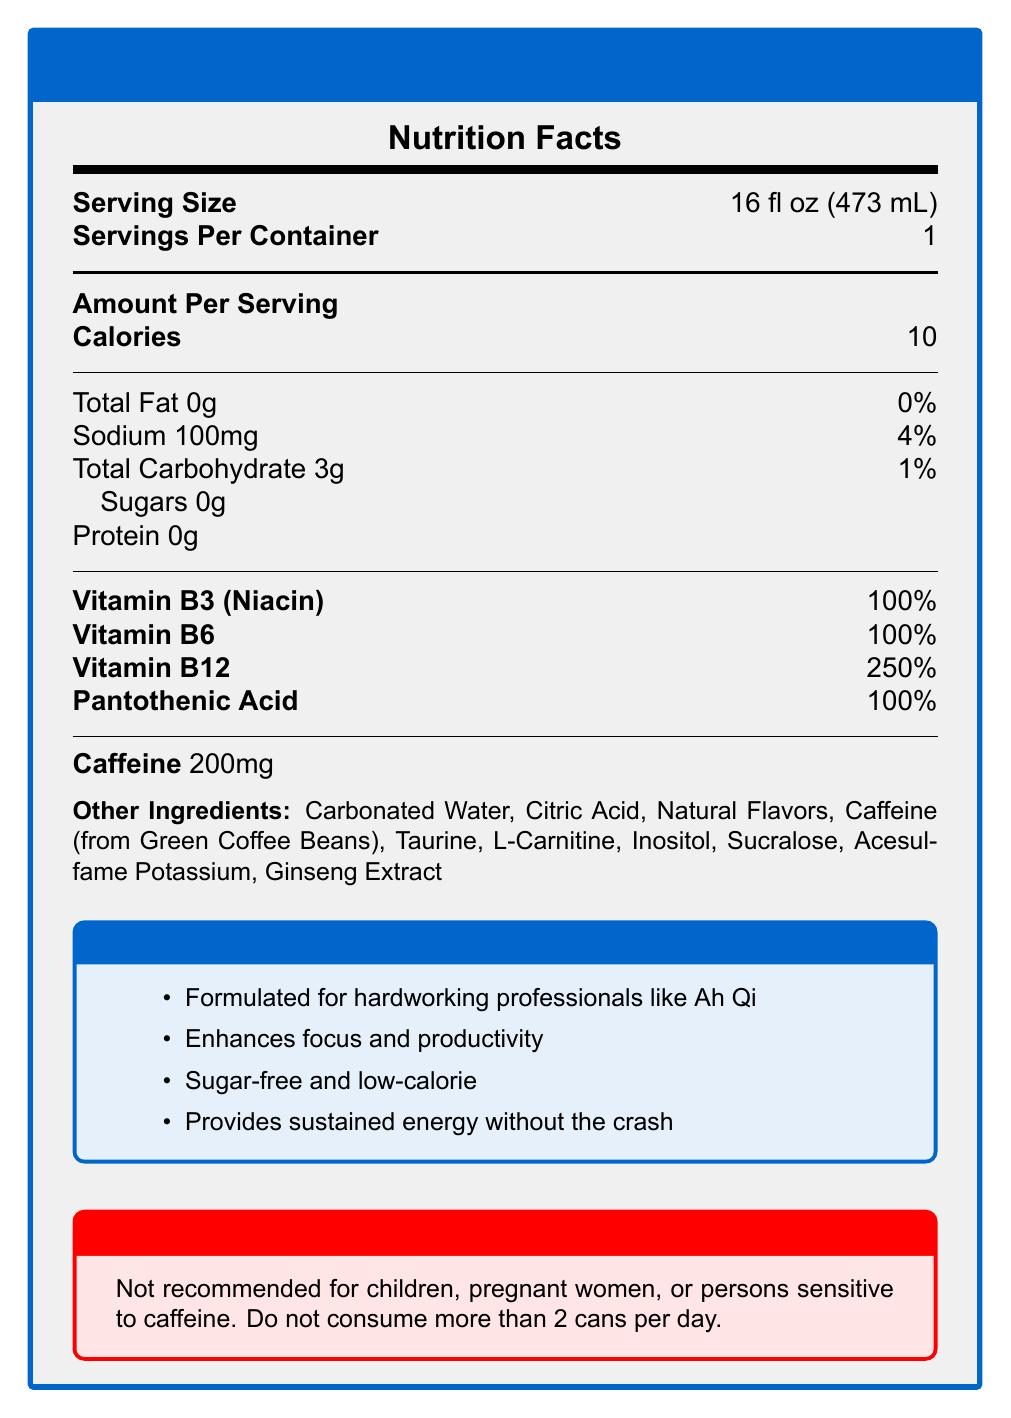what is the serving size for AhQi Power Boost? The document states the serving size as "16 fl oz (473 mL)".
Answer: 16 fl oz (473 mL) how many calories are in one serving of AhQi Power Boost? The Nutrition Facts section lists "Calories" as 10 per serving.
Answer: 10 how much sodium is in AhQi Power Boost? The document states "Sodium: 100mg" in the Nutrition Facts section.
Answer: 100mg what percentage of daily value is Vitamin B12 in AhQi Power Boost? The document lists "Vitamin B12" with a daily value of "250%".
Answer: 250% what are the main ingredients in AhQi Power Boost? The "Other Ingredients" section lists all the main ingredients.
Answer: Carbonated Water, Citric Acid, Natural Flavors, Caffeine (from Green Coffee Beans), Taurine, L-Carnitine, Inositol, Sucralose, Acesulfame Potassium, Ginseng Extract which of the following vitamins and minerals is present in the highest daily value percentage in AhQi Power Boost? A. Vitamin B3 (Niacin) B. Vitamin B6 C. Vitamin B12 D. Pantothenic Acid The document states that "Vitamin B12" has a daily value of 250%, which is the highest among the listed vitamins and minerals.
Answer: C. Vitamin B12 how many servings are in one container of AhQi Power Boost? A. 1 B. 2 C. 3 D. 4 The document states "Servings Per Container" as 1.
Answer: A. 1 is AhQi Power Boost suitable for children? The warning section states "Not recommended for children".
Answer: No is AhQi Power Boost sugar-free? The document claims "sugar-free" marketing claim and lists "Sugars 0g" in the Nutrition Facts section.
Answer: Yes summarize the main idea of the AhQi Power Boost document The document provides detailed nutrition information, ingredient list, and marketing claims for AhQi Power Boost, highlighting its benefits and target audience.
Answer: AhQi Power Boost is an energy drink formulated for hardworking professionals like Ah Qi. It is sugar-free and low-calorie, providing sustained energy without the crash, and contains essential vitamins and minerals. It has a serving size of 16 fl oz, 10 calories, 200mg of caffeine, and various other ingredients. The drink is not recommended for children, pregnant women, or people sensitive to caffeine, with a maximum limit of 2 cans per day. how much caffeine is in a serving of AhQi Power Boost? The document states "Caffeine 200mg" explicitly in the Nutrition Facts section.
Answer: 200mg can the exact amount of taurine in AhQi Power Boost be determined from the document? The document lists "Taurine" as an ingredient but does not provide the exact amount.
Answer: Cannot be determined 